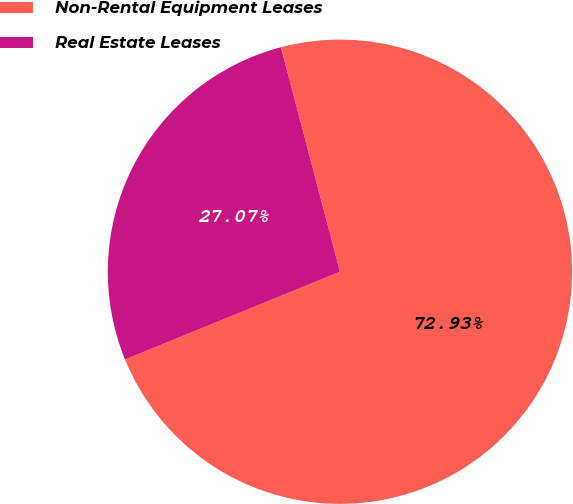Convert chart to OTSL. <chart><loc_0><loc_0><loc_500><loc_500><pie_chart><fcel>Non-Rental Equipment Leases<fcel>Real Estate Leases<nl><fcel>72.93%<fcel>27.07%<nl></chart> 